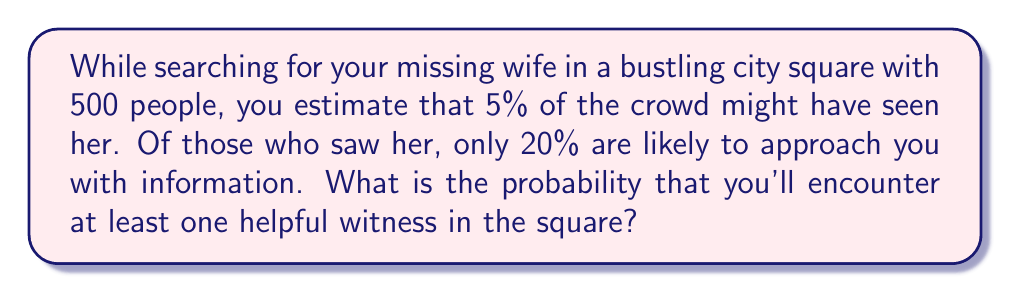Can you answer this question? Let's approach this step-by-step:

1) First, let's calculate the probability of a single person being a helpful witness:
   $P(\text{helpful witness}) = P(\text{saw wife}) \times P(\text{will approach})$
   $P(\text{helpful witness}) = 0.05 \times 0.20 = 0.01$ or 1%

2) Now, we want to find the probability of encountering at least one helpful witness. It's easier to calculate the probability of not encountering any helpful witnesses and then subtract that from 1.

3) The probability of a single person not being a helpful witness is:
   $P(\text{not helpful}) = 1 - P(\text{helpful}) = 1 - 0.01 = 0.99$ or 99%

4) For all 500 people to not be helpful witnesses, we need this to happen 500 times in a row:
   $P(\text{no helpful witnesses}) = (0.99)^{500}$

5) We can calculate this:
   $P(\text{no helpful witnesses}) = (0.99)^{500} \approx 0.0066$

6) Therefore, the probability of encountering at least one helpful witness is:
   $P(\text{at least one helpful witness}) = 1 - P(\text{no helpful witnesses})$
   $P(\text{at least one helpful witness}) = 1 - 0.0066 \approx 0.9934$

7) Converting to a percentage:
   $0.9934 \times 100\% \approx 99.34\%$
Answer: 99.34% 